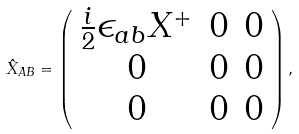<formula> <loc_0><loc_0><loc_500><loc_500>\hat { X } _ { A B } = \left ( \begin{array} { c c c } \frac { i } { 2 } \epsilon _ { a b } X ^ { + } & 0 & 0 \\ 0 & 0 & 0 \\ 0 & 0 & 0 \end{array} \right ) ,</formula> 